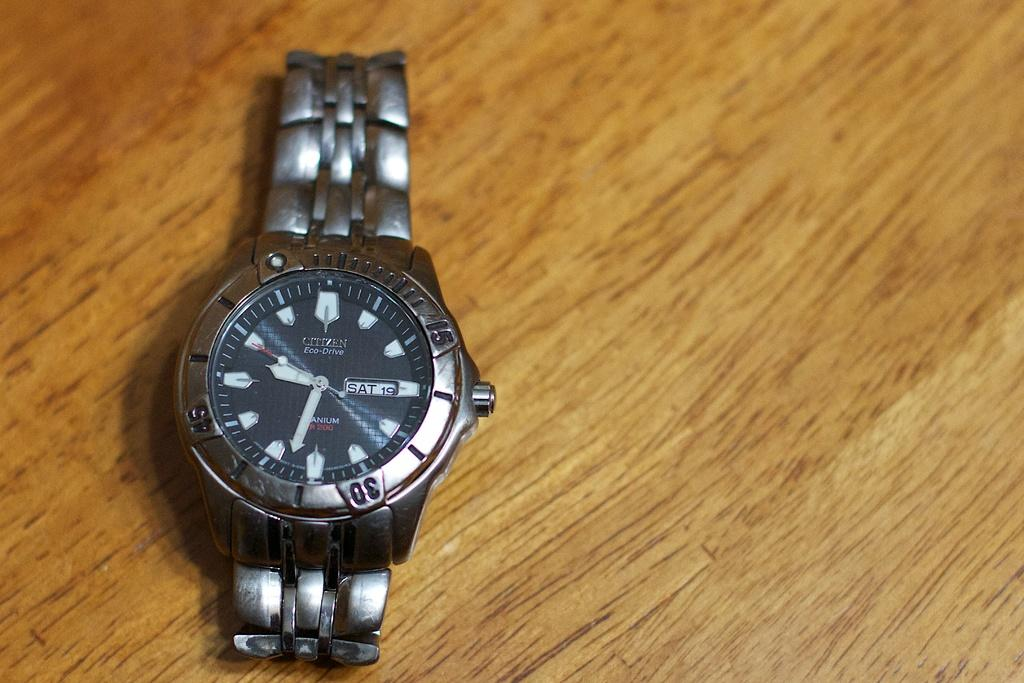<image>
Share a concise interpretation of the image provided. A watch sitting on a wooden table says today is Saturday the 19th. 